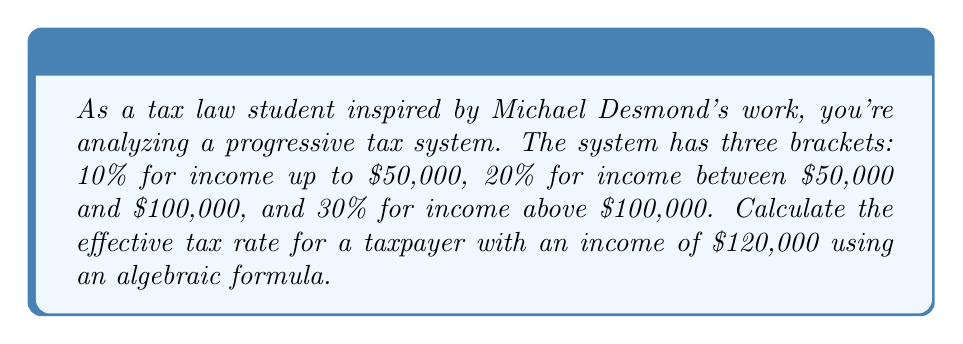Show me your answer to this math problem. Let's approach this step-by-step:

1) First, we need to calculate the tax for each bracket:
   - For the first $50,000: $50,000 * 0.10 = $5,000
   - For the next $50,000 ($50,000 to $100,000): $50,000 * 0.20 = $10,000
   - For the remaining $20,000 (above $100,000): $20,000 * 0.30 = $6,000

2) The total tax is the sum of these: $5,000 + $10,000 + $6,000 = $21,000

3) The effective tax rate is calculated by dividing the total tax by the total income:

   $$ \text{Effective Tax Rate} = \frac{\text{Total Tax}}{\text{Total Income}} * 100\% $$

4) Substituting our values:

   $$ \text{Effective Tax Rate} = \frac{21,000}{120,000} * 100\% $$

5) Simplifying:

   $$ \text{Effective Tax Rate} = 0.175 * 100\% = 17.5\% $$

6) The algebraic formula for this progressive tax system can be expressed as:

   $$ \text{ETR} = \frac{(50,000 * 0.10) + (50,000 * 0.20) + ((I - 100,000) * 0.30)}{I} * 100\% $$

   Where $I$ is the total income and $I > 100,000$.

7) Substituting $I = 120,000$ into this formula would yield the same result of 17.5%.
Answer: 17.5% 